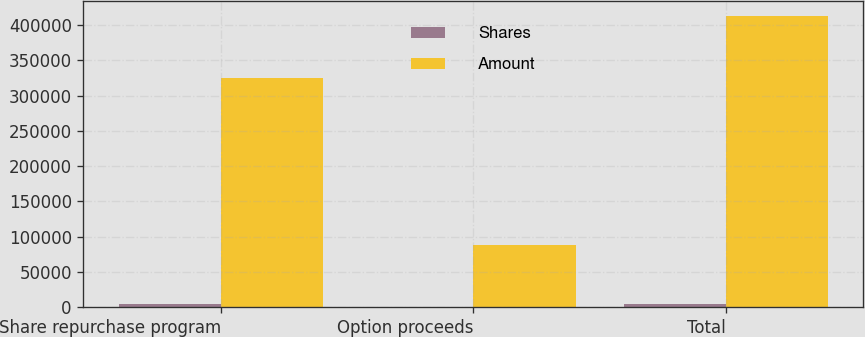Convert chart to OTSL. <chart><loc_0><loc_0><loc_500><loc_500><stacked_bar_chart><ecel><fcel>Share repurchase program<fcel>Option proceeds<fcel>Total<nl><fcel>Shares<fcel>4126<fcel>1103<fcel>5229<nl><fcel>Amount<fcel>324622<fcel>88367<fcel>412989<nl></chart> 